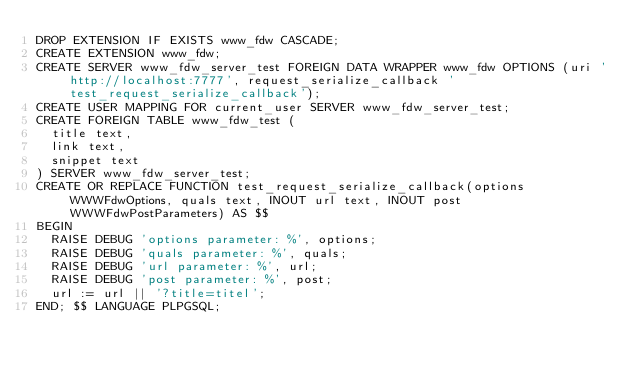Convert code to text. <code><loc_0><loc_0><loc_500><loc_500><_SQL_>DROP EXTENSION IF EXISTS www_fdw CASCADE;
CREATE EXTENSION www_fdw;
CREATE SERVER www_fdw_server_test FOREIGN DATA WRAPPER www_fdw OPTIONS (uri 'http://localhost:7777', request_serialize_callback 'test_request_serialize_callback');
CREATE USER MAPPING FOR current_user SERVER www_fdw_server_test;
CREATE FOREIGN TABLE www_fdw_test (
	title text,                                                        
	link text,
	snippet text
) SERVER www_fdw_server_test;
CREATE OR REPLACE FUNCTION test_request_serialize_callback(options WWWFdwOptions, quals text, INOUT url text, INOUT post WWWFdwPostParameters) AS $$
BEGIN
	RAISE DEBUG 'options parameter: %', options;
	RAISE DEBUG 'quals parameter: %', quals;
	RAISE DEBUG 'url parameter: %', url;
	RAISE DEBUG 'post parameter: %', post;
	url := url || '?title=titel';
END; $$ LANGUAGE PLPGSQL;</code> 